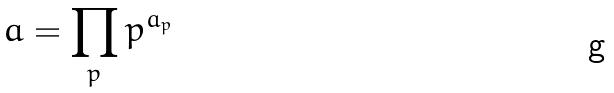Convert formula to latex. <formula><loc_0><loc_0><loc_500><loc_500>a = \prod _ { p } p ^ { a _ { p } }</formula> 